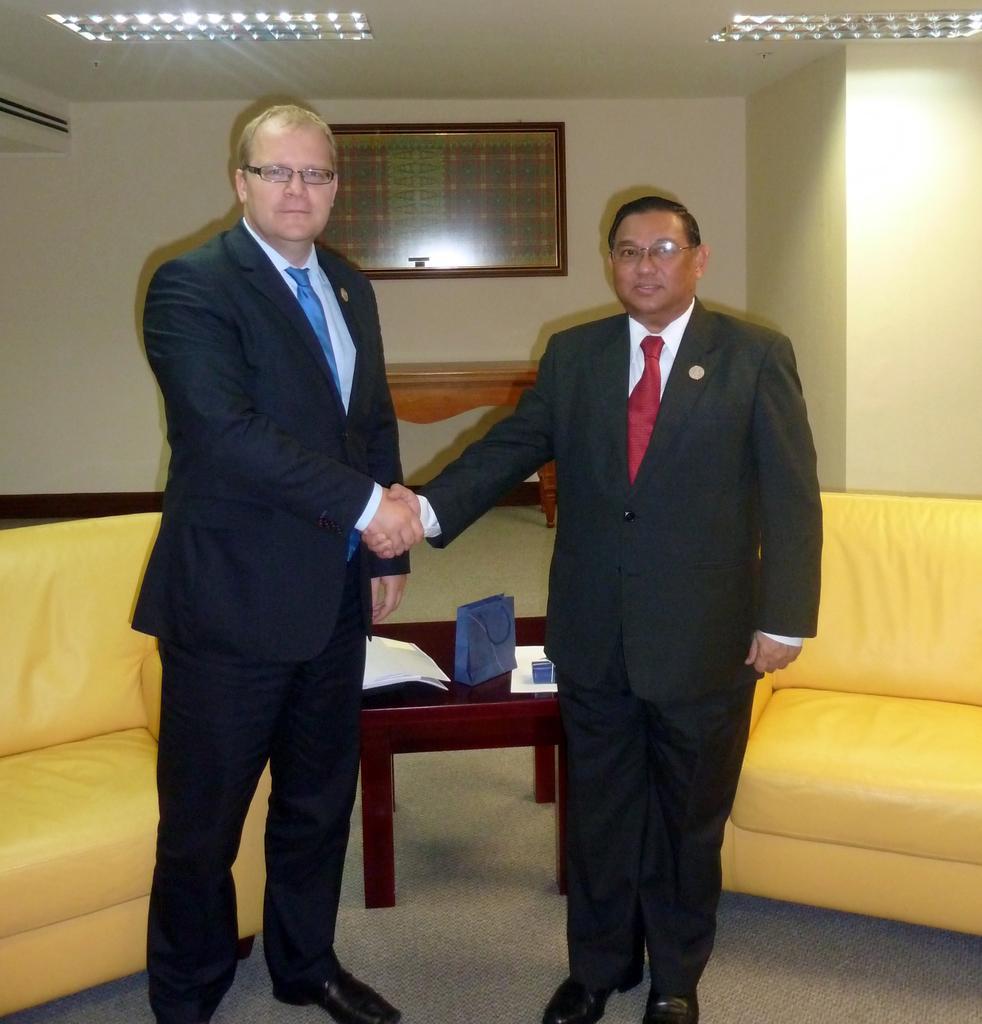How would you summarize this image in a sentence or two? In this image i can see 2 persons wearing black blazers and black pants shaking hands. In the background i can see 2 couches and a table on which there are few objects, the wall, the ceiling, 2 lights to the ceiling and a photo frame attached to the wall. 